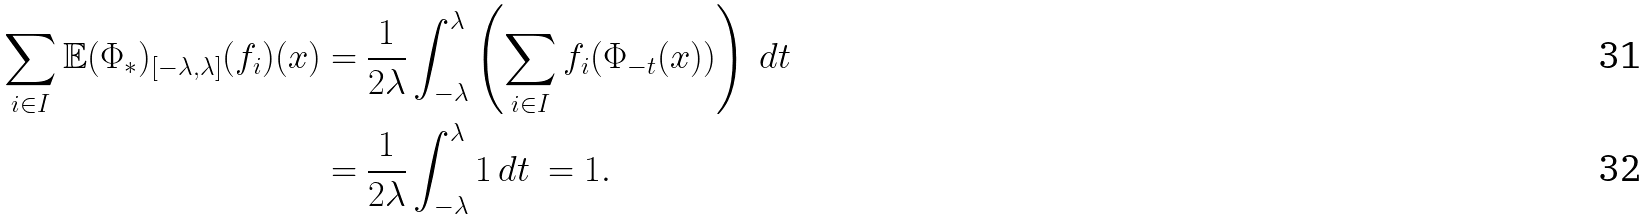<formula> <loc_0><loc_0><loc_500><loc_500>\sum _ { i \in I } \mathbb { E } ( \Phi _ { * } ) _ { \left [ - \lambda , \lambda \right ] } ( f _ { i } ) ( x ) = \ & \frac { 1 } { 2 \lambda } \int _ { - \lambda } ^ { \lambda } \left ( \sum _ { i \in I } f _ { i } ( \Phi _ { - t } ( x ) ) \right ) \ d t \\ = \ & \frac { 1 } { 2 \lambda } \int _ { - \lambda } ^ { \lambda } 1 \, d t \ = 1 .</formula> 